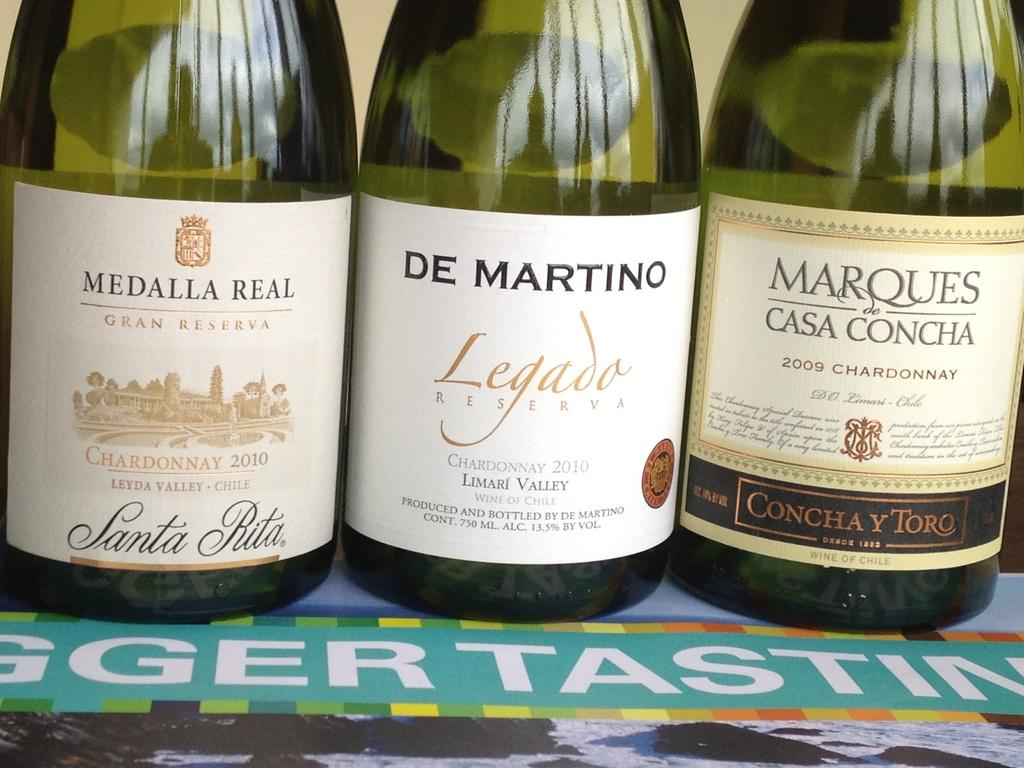<image>
Share a concise interpretation of the image provided. Three bottles of wine in a row and all are Chardonnays. 